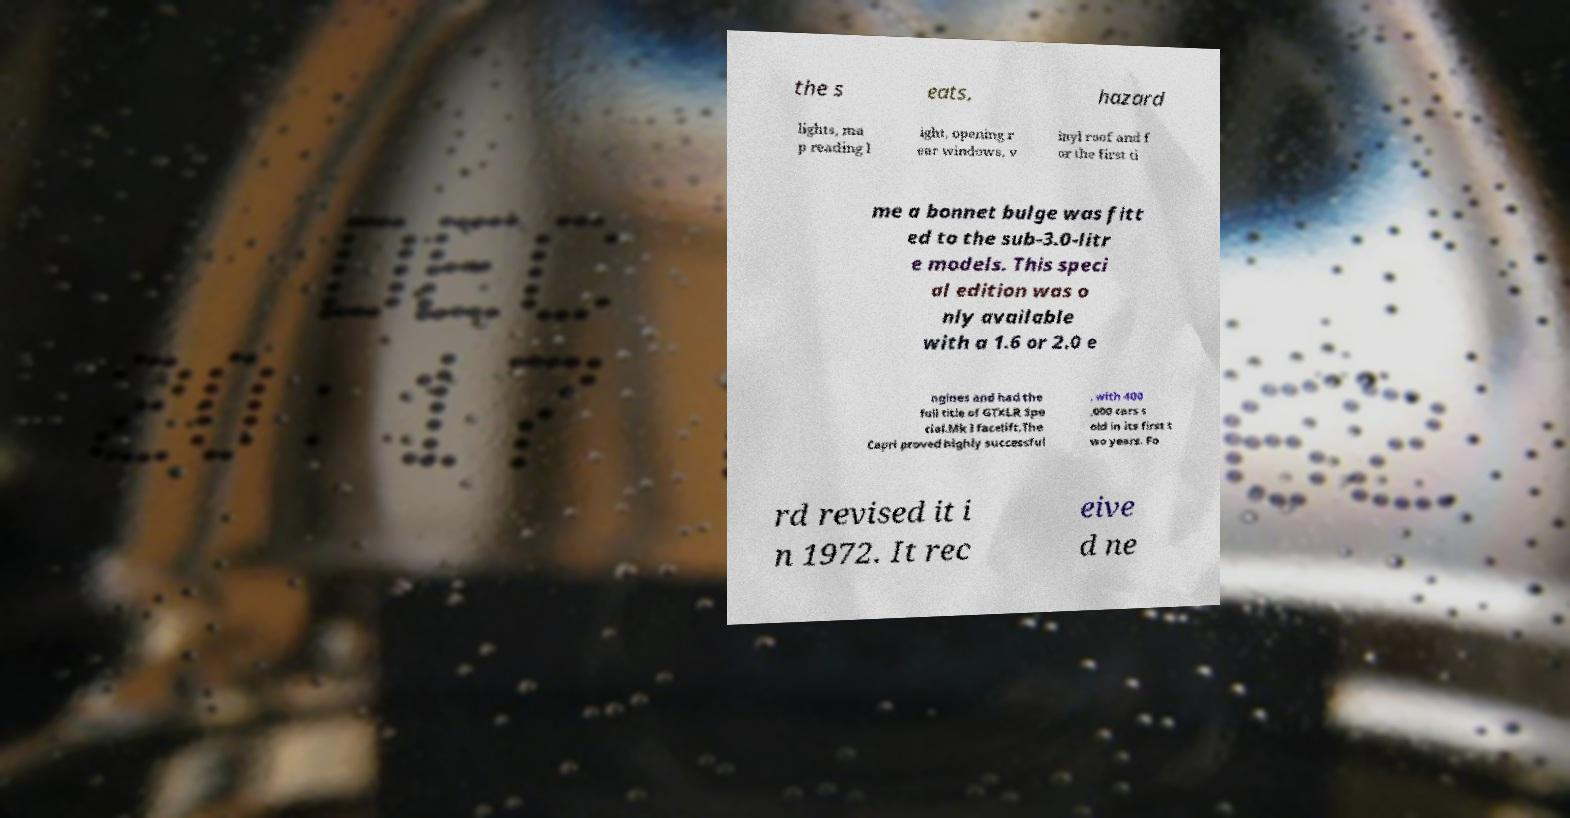Can you accurately transcribe the text from the provided image for me? the s eats, hazard lights, ma p reading l ight, opening r ear windows, v inyl roof and f or the first ti me a bonnet bulge was fitt ed to the sub-3.0-litr e models. This speci al edition was o nly available with a 1.6 or 2.0 e ngines and had the full title of GTXLR Spe cial.Mk I facelift.The Capri proved highly successful , with 400 ,000 cars s old in its first t wo years. Fo rd revised it i n 1972. It rec eive d ne 